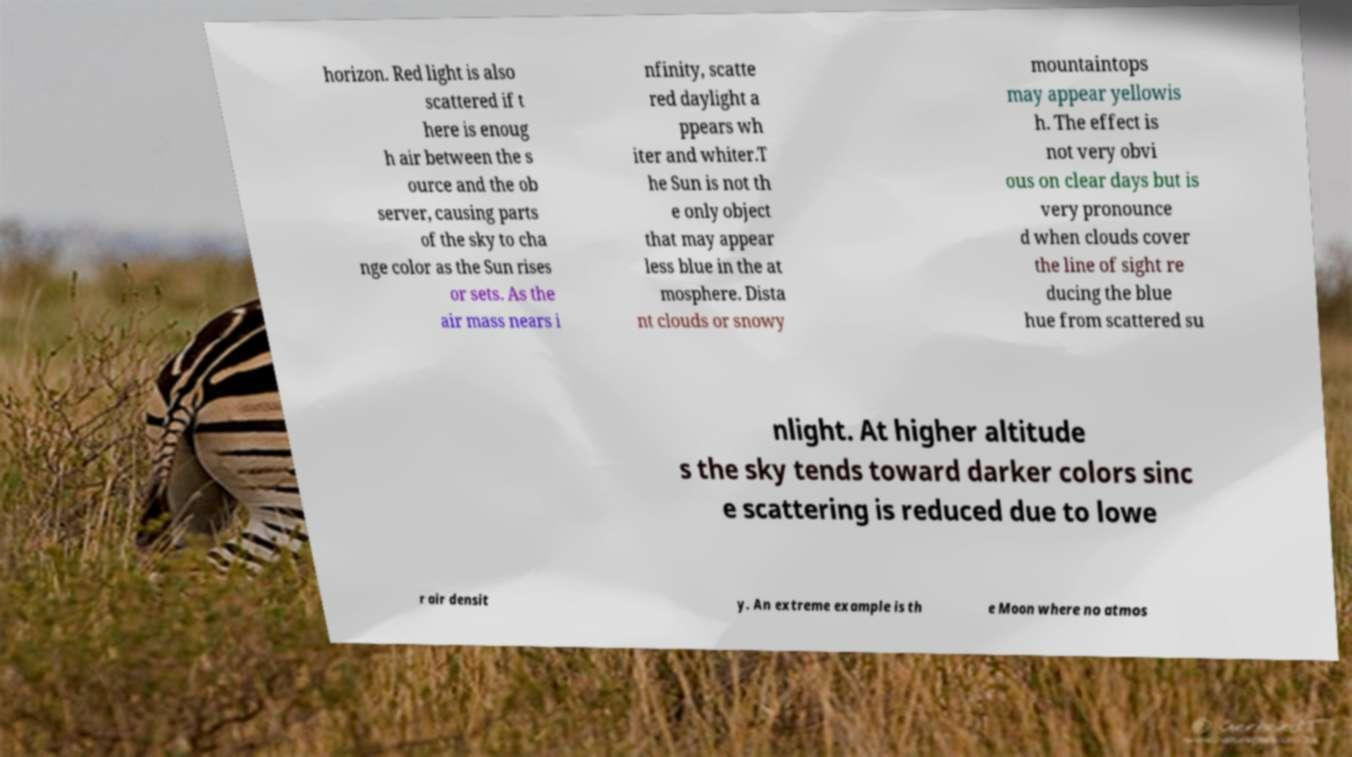Could you extract and type out the text from this image? horizon. Red light is also scattered if t here is enoug h air between the s ource and the ob server, causing parts of the sky to cha nge color as the Sun rises or sets. As the air mass nears i nfinity, scatte red daylight a ppears wh iter and whiter.T he Sun is not th e only object that may appear less blue in the at mosphere. Dista nt clouds or snowy mountaintops may appear yellowis h. The effect is not very obvi ous on clear days but is very pronounce d when clouds cover the line of sight re ducing the blue hue from scattered su nlight. At higher altitude s the sky tends toward darker colors sinc e scattering is reduced due to lowe r air densit y. An extreme example is th e Moon where no atmos 